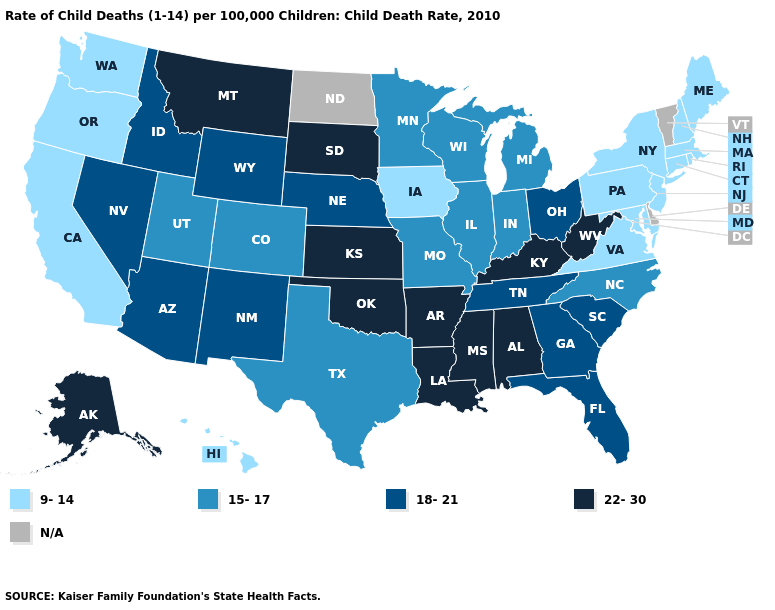Name the states that have a value in the range 22-30?
Answer briefly. Alabama, Alaska, Arkansas, Kansas, Kentucky, Louisiana, Mississippi, Montana, Oklahoma, South Dakota, West Virginia. Among the states that border South Dakota , which have the highest value?
Keep it brief. Montana. What is the highest value in states that border South Carolina?
Be succinct. 18-21. What is the highest value in the South ?
Quick response, please. 22-30. Name the states that have a value in the range 9-14?
Quick response, please. California, Connecticut, Hawaii, Iowa, Maine, Maryland, Massachusetts, New Hampshire, New Jersey, New York, Oregon, Pennsylvania, Rhode Island, Virginia, Washington. What is the value of New Hampshire?
Be succinct. 9-14. Among the states that border Colorado , which have the lowest value?
Answer briefly. Utah. What is the lowest value in the MidWest?
Concise answer only. 9-14. Name the states that have a value in the range N/A?
Quick response, please. Delaware, North Dakota, Vermont. What is the highest value in the West ?
Keep it brief. 22-30. What is the highest value in the USA?
Write a very short answer. 22-30. Which states hav the highest value in the Northeast?
Be succinct. Connecticut, Maine, Massachusetts, New Hampshire, New Jersey, New York, Pennsylvania, Rhode Island. Name the states that have a value in the range 15-17?
Short answer required. Colorado, Illinois, Indiana, Michigan, Minnesota, Missouri, North Carolina, Texas, Utah, Wisconsin. What is the lowest value in the USA?
Concise answer only. 9-14. What is the lowest value in the MidWest?
Keep it brief. 9-14. 